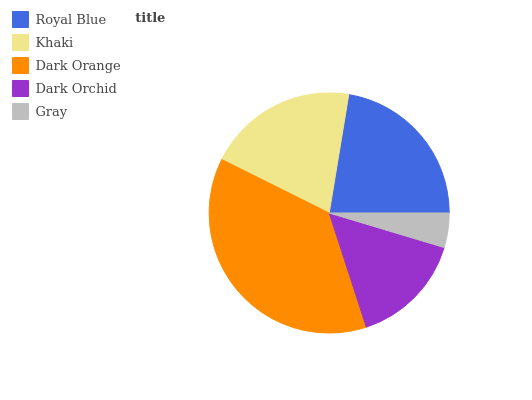Is Gray the minimum?
Answer yes or no. Yes. Is Dark Orange the maximum?
Answer yes or no. Yes. Is Khaki the minimum?
Answer yes or no. No. Is Khaki the maximum?
Answer yes or no. No. Is Royal Blue greater than Khaki?
Answer yes or no. Yes. Is Khaki less than Royal Blue?
Answer yes or no. Yes. Is Khaki greater than Royal Blue?
Answer yes or no. No. Is Royal Blue less than Khaki?
Answer yes or no. No. Is Khaki the high median?
Answer yes or no. Yes. Is Khaki the low median?
Answer yes or no. Yes. Is Royal Blue the high median?
Answer yes or no. No. Is Royal Blue the low median?
Answer yes or no. No. 